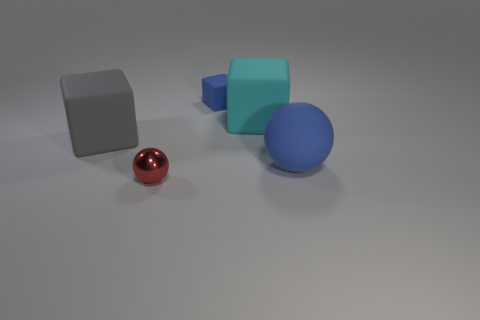How many other objects are the same material as the cyan block?
Offer a very short reply. 3. There is a blue object that is behind the large cyan cube; is its shape the same as the metallic object?
Your answer should be compact. No. How many tiny things are matte cubes or red matte blocks?
Make the answer very short. 1. Is the number of large cyan blocks in front of the large gray matte block the same as the number of tiny blocks behind the small matte block?
Offer a terse response. Yes. What number of other objects are there of the same color as the tiny block?
Offer a very short reply. 1. There is a tiny metallic object; is it the same color as the block on the right side of the tiny blue rubber thing?
Your answer should be very brief. No. What number of blue objects are big things or big balls?
Your answer should be compact. 1. Is the number of blue rubber balls that are in front of the tiny red thing the same as the number of red objects?
Provide a short and direct response. No. Is there anything else that is the same size as the blue cube?
Provide a short and direct response. Yes. What color is the tiny thing that is the same shape as the large cyan matte thing?
Make the answer very short. Blue. 